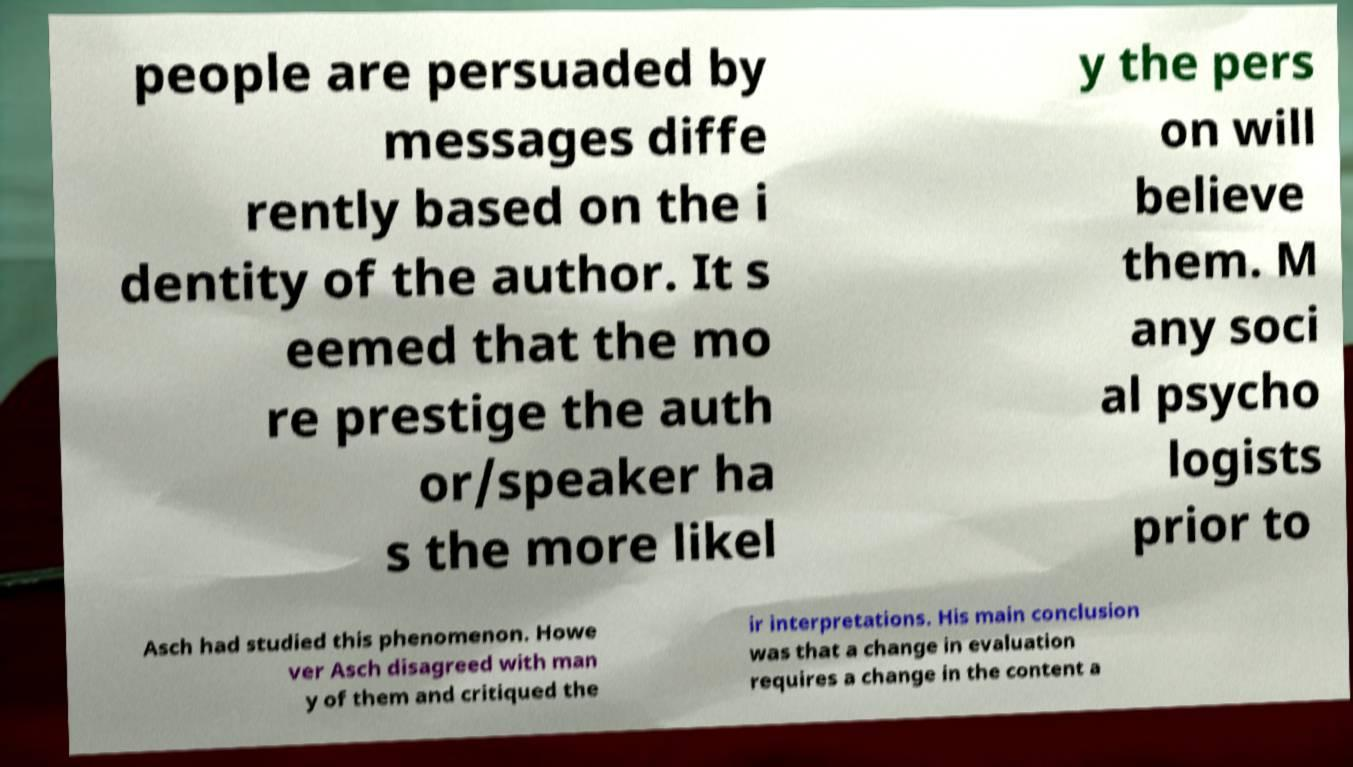For documentation purposes, I need the text within this image transcribed. Could you provide that? people are persuaded by messages diffe rently based on the i dentity of the author. It s eemed that the mo re prestige the auth or/speaker ha s the more likel y the pers on will believe them. M any soci al psycho logists prior to Asch had studied this phenomenon. Howe ver Asch disagreed with man y of them and critiqued the ir interpretations. His main conclusion was that a change in evaluation requires a change in the content a 